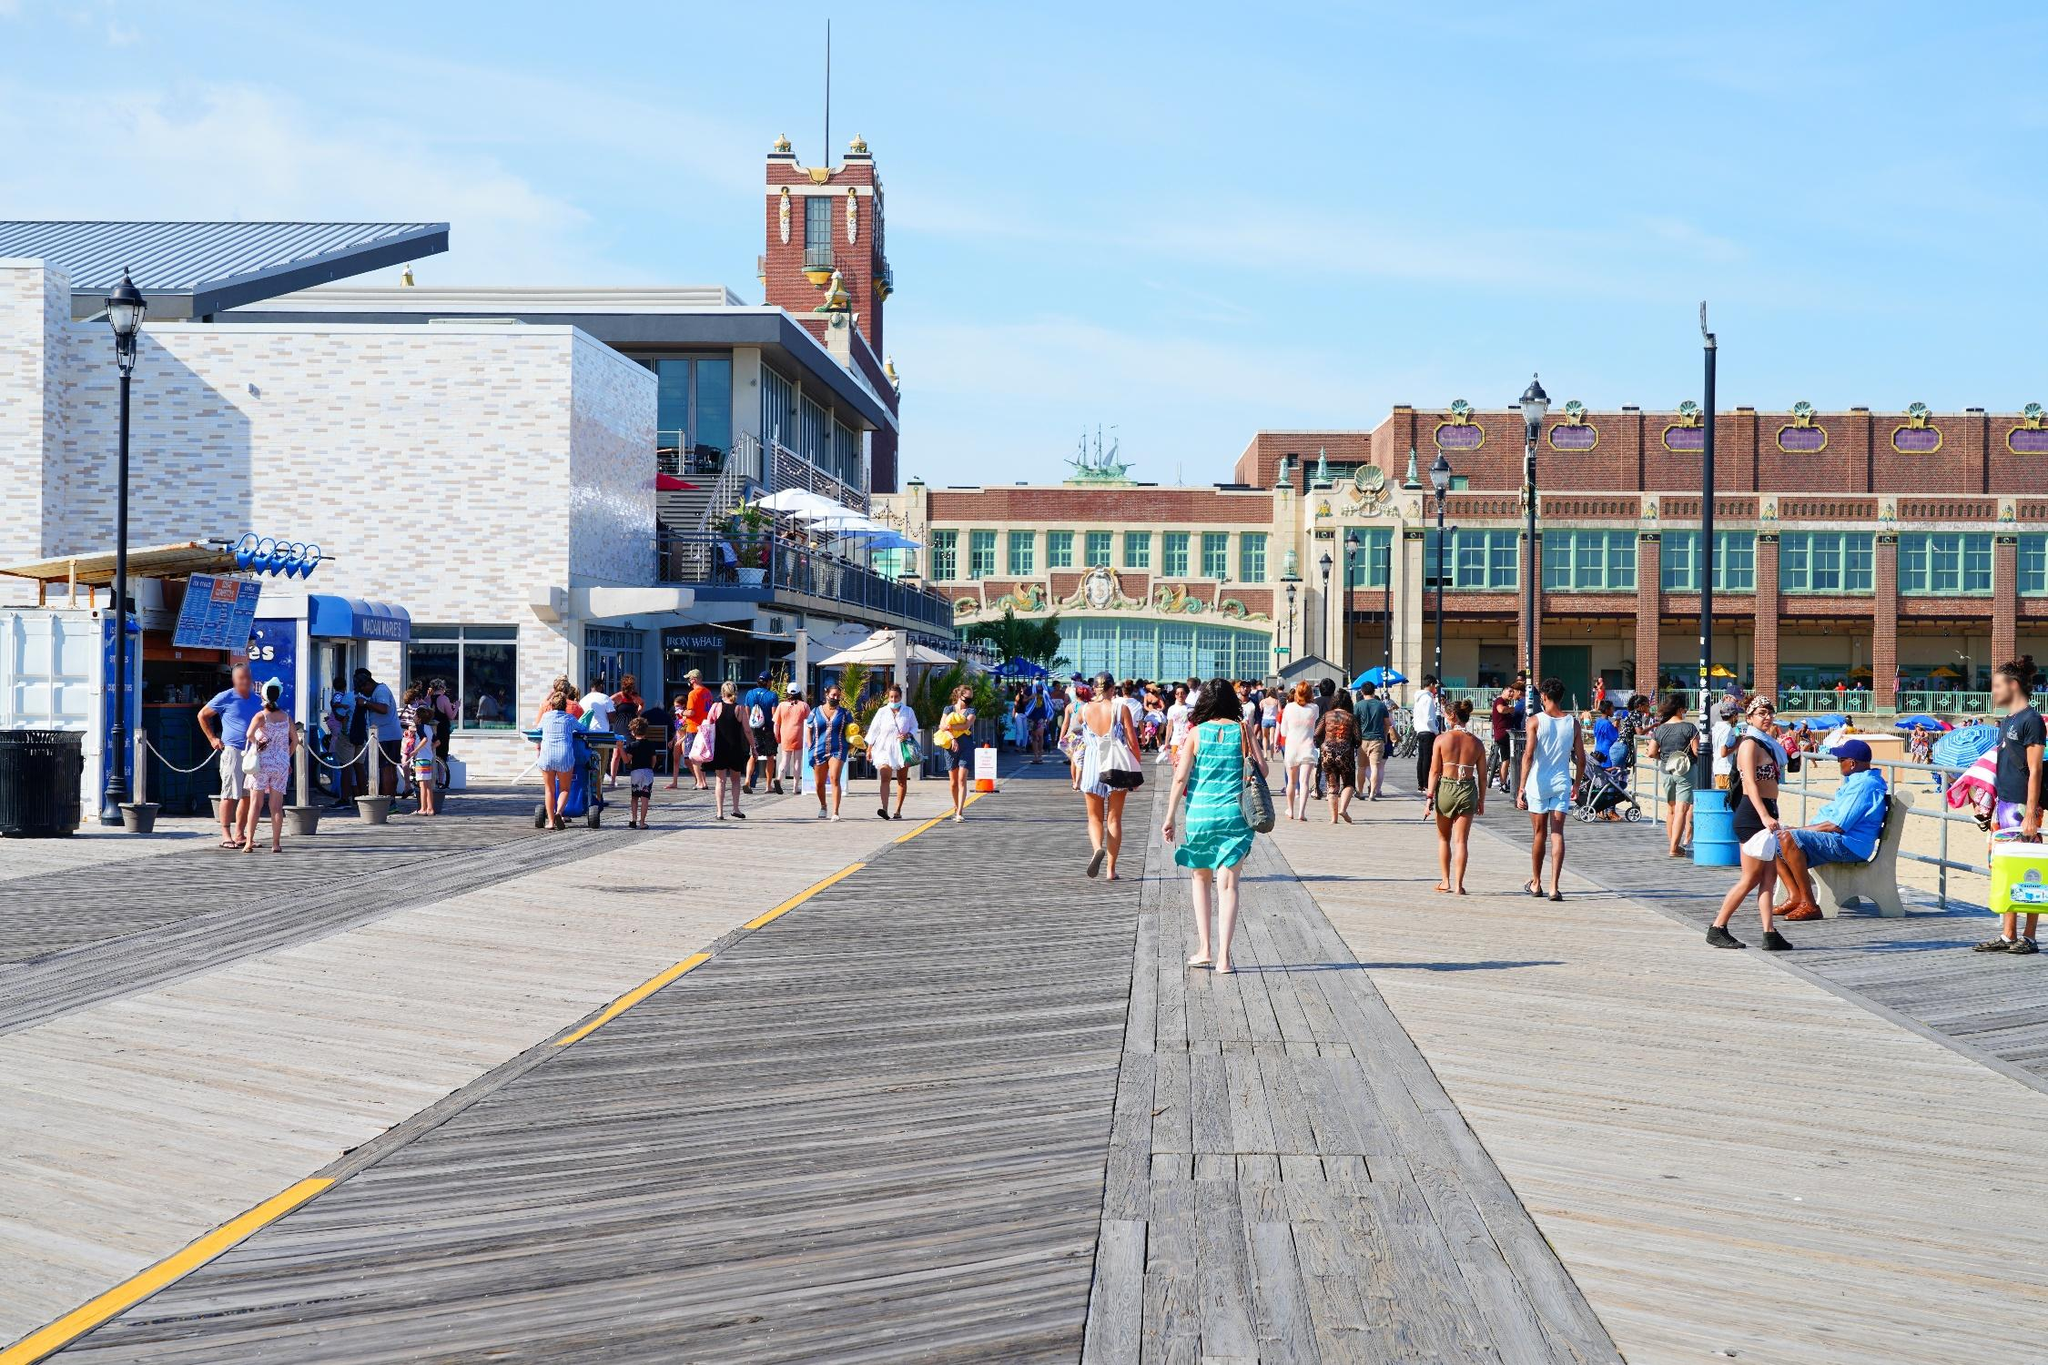Can you elaborate on the elements of the picture provided? The image shows a bustling boardwalk filled with people enjoying a sunny day. The wide boardwalk, made of wooden planks, extends into the distance and is bordered on both sides by various shops and eateries. The buildings, primarily painted in white and accented with blue, have a charming coastal aesthetic. On the left side, there's a little food stand where people are queuing up for refreshments. In the middle distance, a prominent brick clock tower rises, giving character to the scene. The entire setting suggests a vibrant and welcoming atmosphere perfect for leisure activities. The clear blue sky overhead hints at pleasant weather, making it an ideal day for a stroll or casual outdoor dining. Despite the crowd, the scene exudes a sense of order and harmony. 